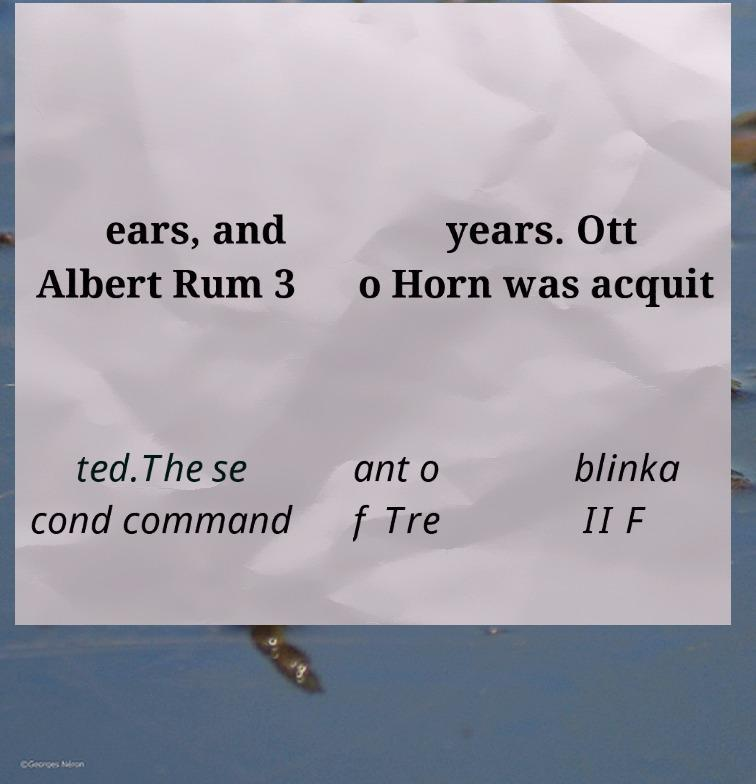I need the written content from this picture converted into text. Can you do that? ears, and Albert Rum 3 years. Ott o Horn was acquit ted.The se cond command ant o f Tre blinka II F 